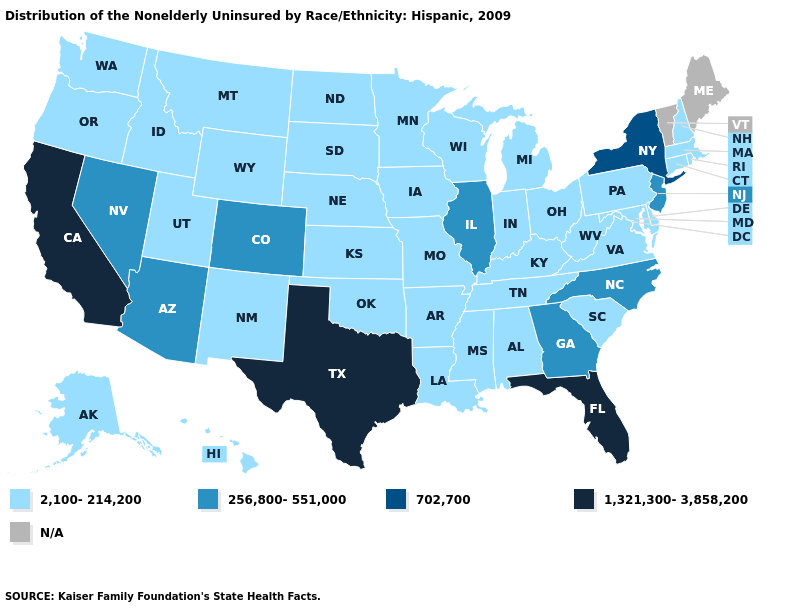Name the states that have a value in the range 702,700?
Answer briefly. New York. Does Pennsylvania have the lowest value in the Northeast?
Short answer required. Yes. Name the states that have a value in the range 2,100-214,200?
Short answer required. Alabama, Alaska, Arkansas, Connecticut, Delaware, Hawaii, Idaho, Indiana, Iowa, Kansas, Kentucky, Louisiana, Maryland, Massachusetts, Michigan, Minnesota, Mississippi, Missouri, Montana, Nebraska, New Hampshire, New Mexico, North Dakota, Ohio, Oklahoma, Oregon, Pennsylvania, Rhode Island, South Carolina, South Dakota, Tennessee, Utah, Virginia, Washington, West Virginia, Wisconsin, Wyoming. Name the states that have a value in the range 256,800-551,000?
Short answer required. Arizona, Colorado, Georgia, Illinois, Nevada, New Jersey, North Carolina. What is the value of New Jersey?
Short answer required. 256,800-551,000. Which states have the lowest value in the Northeast?
Write a very short answer. Connecticut, Massachusetts, New Hampshire, Pennsylvania, Rhode Island. Name the states that have a value in the range 256,800-551,000?
Be succinct. Arizona, Colorado, Georgia, Illinois, Nevada, New Jersey, North Carolina. Which states have the highest value in the USA?
Concise answer only. California, Florida, Texas. Name the states that have a value in the range 1,321,300-3,858,200?
Short answer required. California, Florida, Texas. What is the value of New York?
Be succinct. 702,700. Does New York have the highest value in the Northeast?
Keep it brief. Yes. Which states hav the highest value in the South?
Write a very short answer. Florida, Texas. Does the map have missing data?
Write a very short answer. Yes. Which states have the highest value in the USA?
Quick response, please. California, Florida, Texas. Is the legend a continuous bar?
Keep it brief. No. 